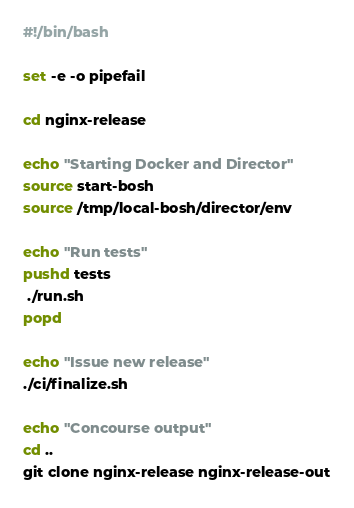Convert code to text. <code><loc_0><loc_0><loc_500><loc_500><_Bash_>#!/bin/bash

set -e -o pipefail

cd nginx-release

echo "Starting Docker and Director"
source start-bosh
source /tmp/local-bosh/director/env

echo "Run tests"
pushd tests
 ./run.sh
popd

echo "Issue new release"
./ci/finalize.sh

echo "Concourse output"
cd ..
git clone nginx-release nginx-release-out
</code> 